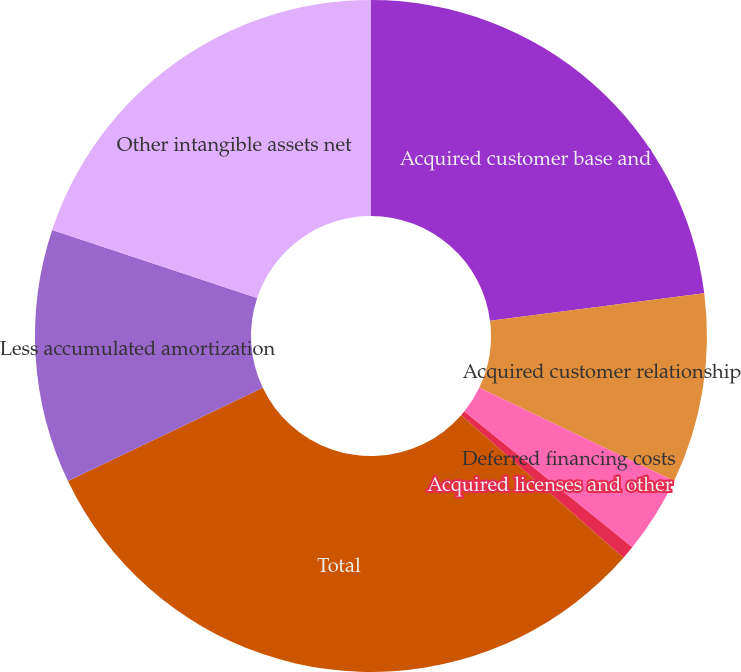Convert chart. <chart><loc_0><loc_0><loc_500><loc_500><pie_chart><fcel>Acquired customer base and<fcel>Acquired customer relationship<fcel>Deferred financing costs<fcel>Acquired licenses and other<fcel>Total<fcel>Less accumulated amortization<fcel>Other intangible assets net<nl><fcel>22.97%<fcel>9.14%<fcel>3.72%<fcel>0.64%<fcel>31.43%<fcel>12.22%<fcel>19.89%<nl></chart> 